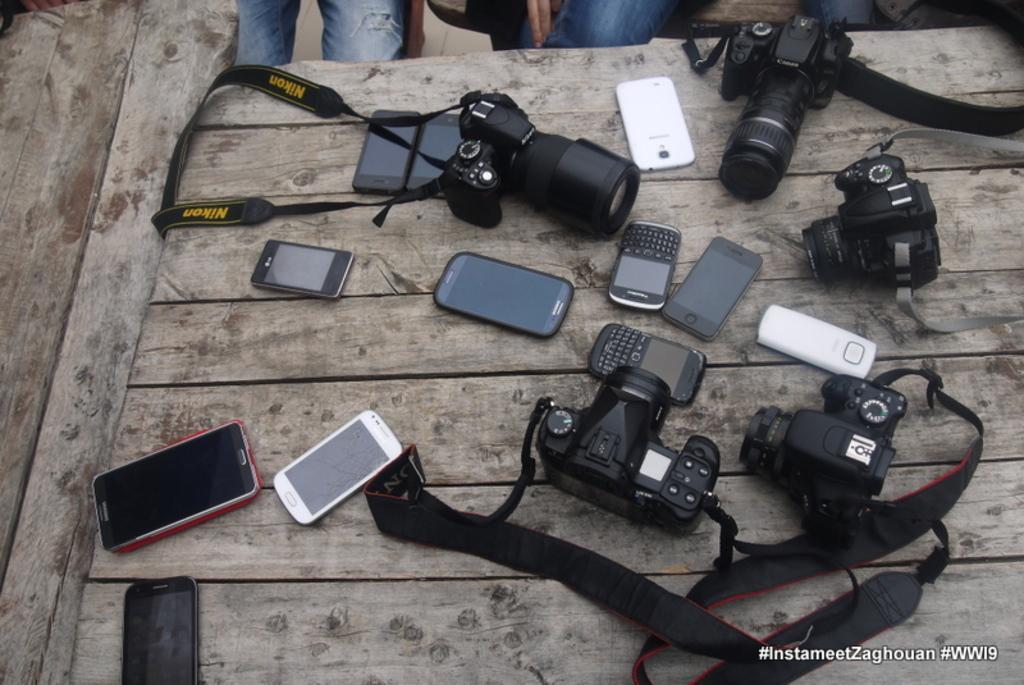Can you describe this image briefly? In this image we can see a wooden surface. On that there are mobiles and cameras. At the top we can see legs of persons. In the right bottom corner there is something written. 